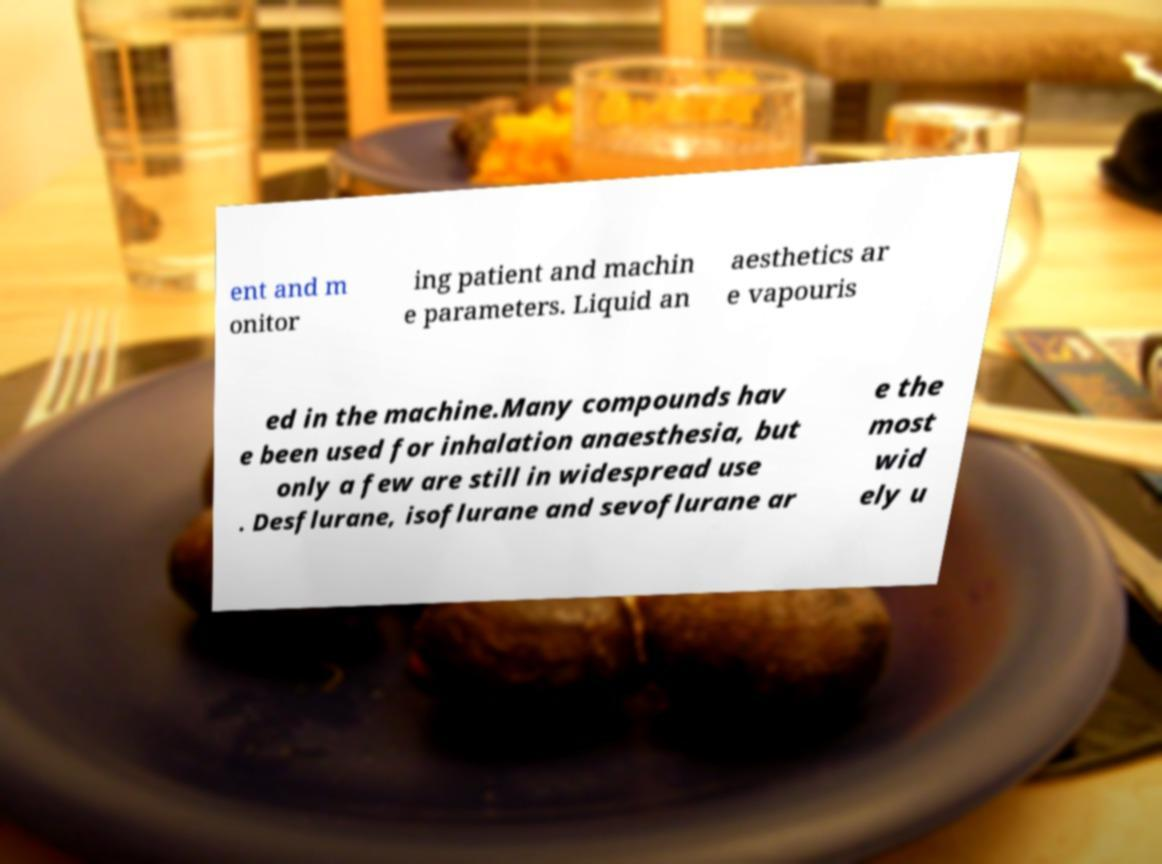What messages or text are displayed in this image? I need them in a readable, typed format. ent and m onitor ing patient and machin e parameters. Liquid an aesthetics ar e vapouris ed in the machine.Many compounds hav e been used for inhalation anaesthesia, but only a few are still in widespread use . Desflurane, isoflurane and sevoflurane ar e the most wid ely u 